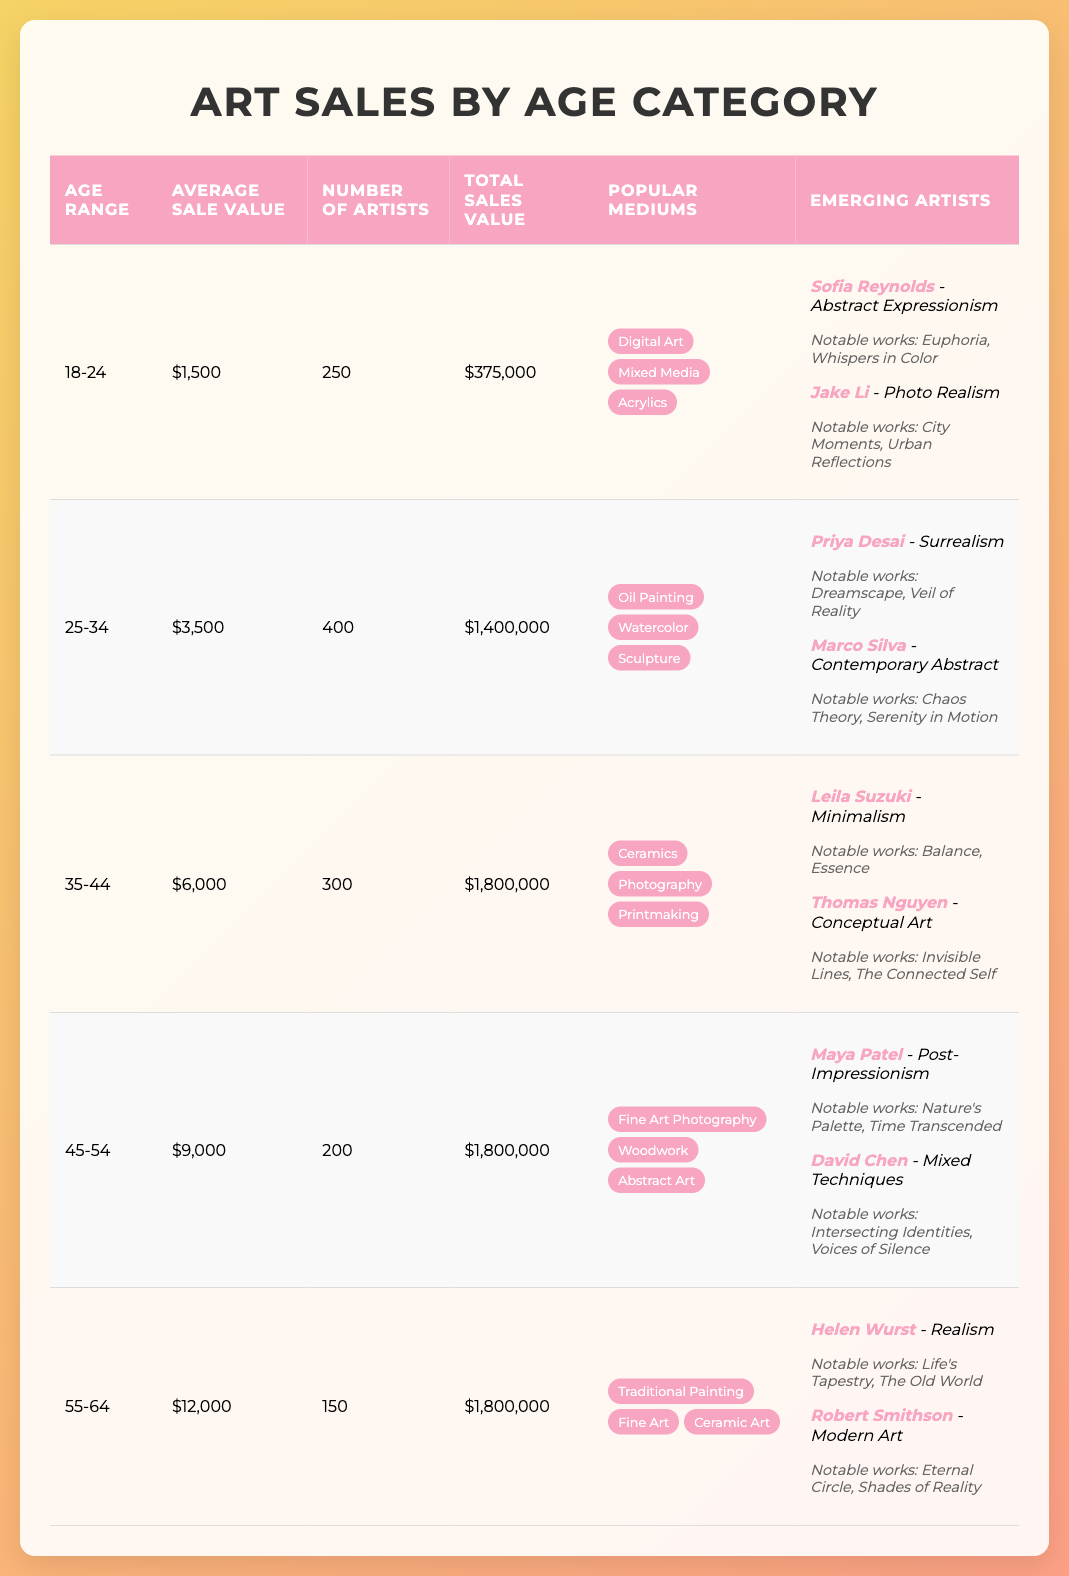What is the average sale value for artists aged 35-44? The average sale value for artists in the age range of 35-44 is listed directly in the table as $6,000.
Answer: $6,000 What is the total sales value for the age group 25-34? Looking at the table, the total sales value for the age group 25-34 is specified as $1,400,000.
Answer: $1,400,000 Which age category has the highest average sale value? The average sale values for each age category are $1,500, $3,500, $6,000, $9,000, and $12,000. The highest average is $12,000 for the 55-64 age range.
Answer: 55-64 How many artists are there in the 45-54 age range? The table indicates there are 200 artists in the 45-54 age range, which is recorded directly in the artist count column for that age category.
Answer: 200 Are there more artists in the age range of 18-24 than those in the age range of 55-64? The number of artists for the age range 18-24 is 250, while the number for 55-64 is 150. Since 250 is greater than 150, the answer is yes.
Answer: Yes What is the total sales value for artists aged 18-24 compared to the total for those aged 25-34? The total sales value for artists aged 18-24 is $375,000, and for those aged 25-34, it is $1,400,000. When compared, $1,400,000 is significantly higher than $375,000.
Answer: 25-34 If we combine the average sale values of all age categories, what is the total? To calculate the total, we sum the average sale values: 1,500 + 3,500 + 6,000 + 9,000 + 12,000 = 32,000.
Answer: $32,000 Which popular medium is associated with the most age categories? By reviewing the popular mediums across all age groups, "fine art" appears in both 45-54 and 55-64, while other mediums do not appear across as many categories. Hence, "fine art" is associated with two age groups.
Answer: Fine Art How many emerging artists does each age group have? Each age group listed in the table has two emerging artists mentioned under that category.
Answer: 2 per age group 